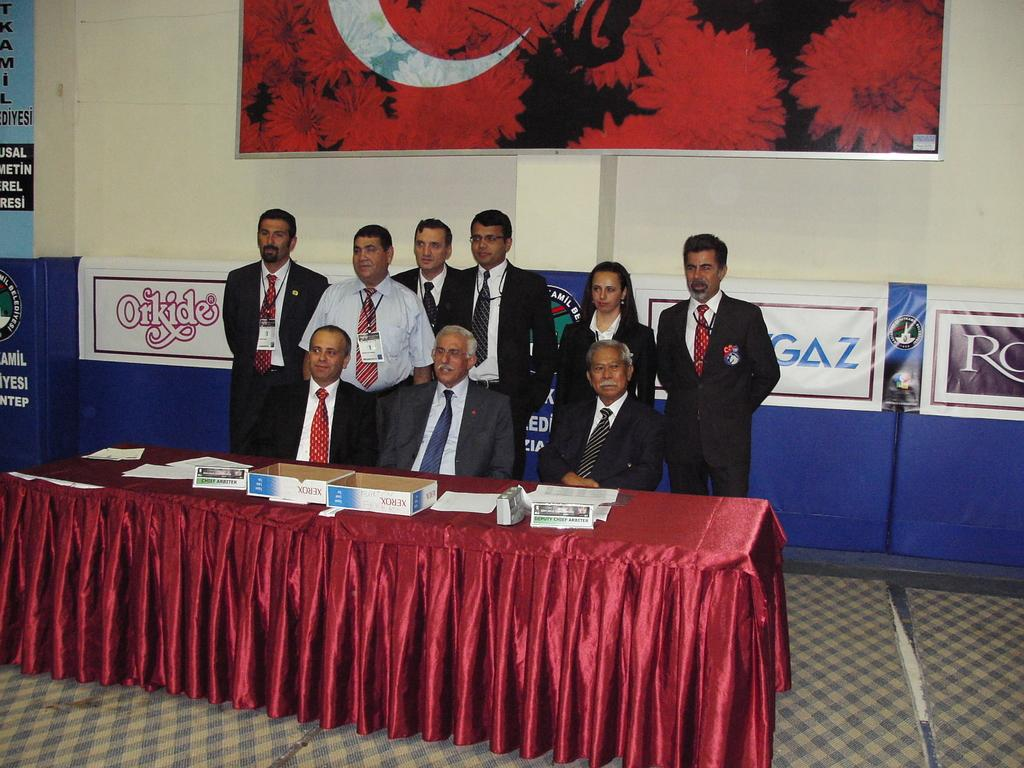How many people are sitting in the image? There are three persons sitting in the image. What are the other people in the image doing? There is a group of people standing in the image. What can be seen hanging in the image? There are banners in the image. What is on the wall in the image? There is a board on the wall in the image. What is on the table in the image? There are papers, boxes, and other items on the table in the image. What type of development is being offered by the person holding the hook in the image? There is no person holding a hook in the image, and therefore no development or offer can be associated with it. 